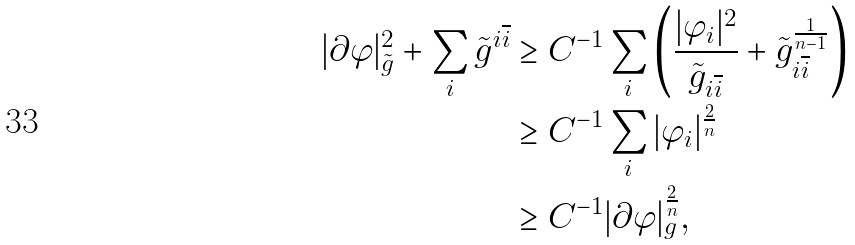Convert formula to latex. <formula><loc_0><loc_0><loc_500><loc_500>| \partial \varphi | _ { \tilde { g } } ^ { 2 } + \sum _ { i } \tilde { g } ^ { i \overline { i } } & \geq C ^ { - 1 } \sum _ { i } \left ( \frac { | \varphi _ { i } | ^ { 2 } } { \tilde { g } _ { i \overline { i } } } + \tilde { g } _ { i \overline { i } } ^ { \frac { 1 } { n - 1 } } \right ) \\ & \geq C ^ { - 1 } \sum _ { i } | \varphi _ { i } | ^ { \frac { 2 } { n } } \\ & \geq C ^ { - 1 } | \partial \varphi | _ { g } ^ { \frac { 2 } { n } } ,</formula> 